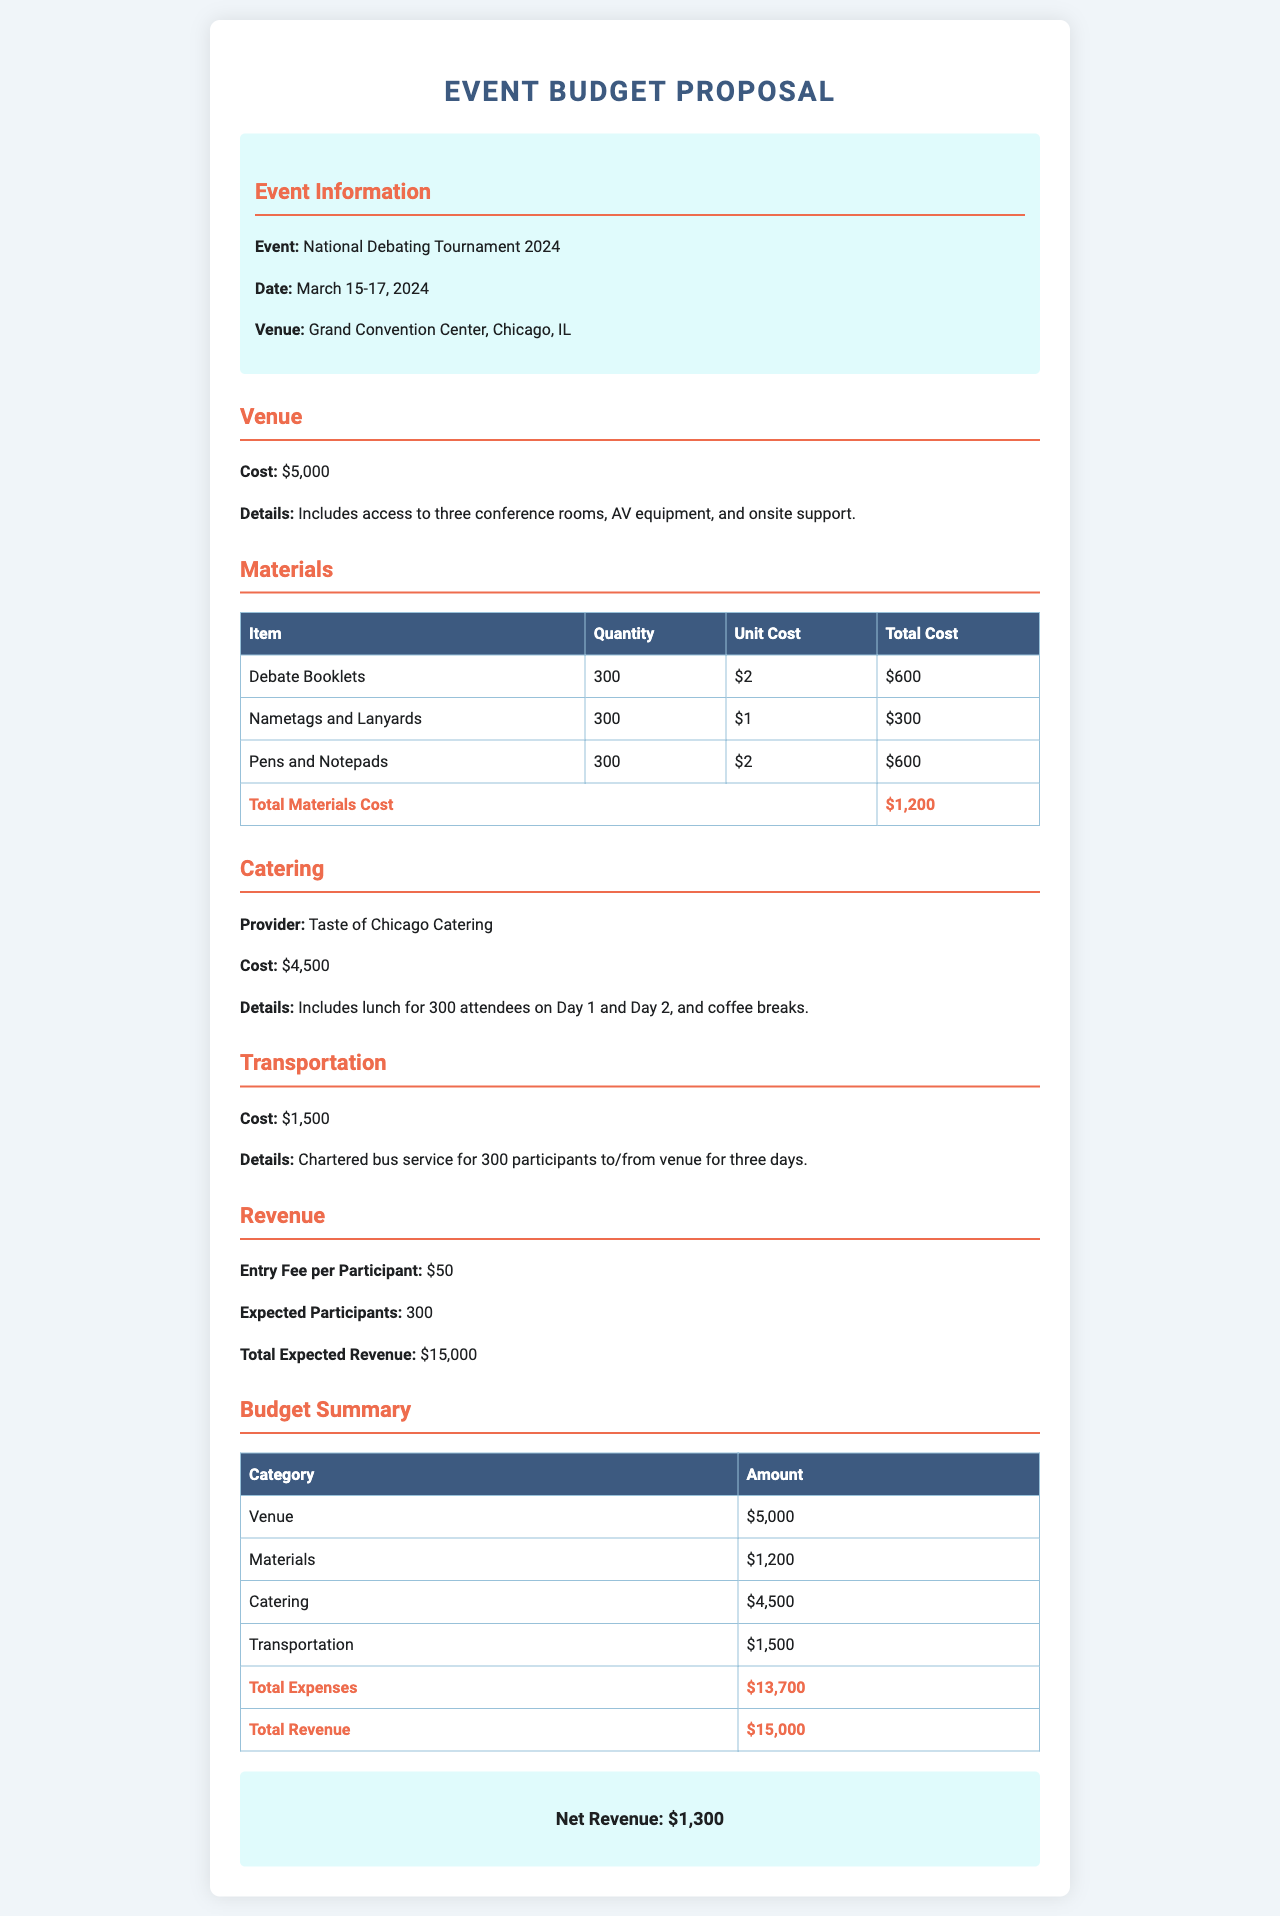What is the event date? The event date is specified in the document as March 15-17, 2024.
Answer: March 15-17, 2024 What is the total cost for the venue? The document lists the cost for the venue as $5,000.
Answer: $5,000 How many debate booklets are being printed? There are 300 debate booklets mentioned in the materials section of the document.
Answer: 300 What is the total expected revenue? The total expected revenue is calculated based on the entry fee and the expected number of participants, which is $15,000.
Answer: $15,000 What is the transportation cost? The cost for transportation is stated in the document as $1,500.
Answer: $1,500 How many participants are expected in the tournament? The expected number of participants mentioned in the document is 300.
Answer: 300 What is the net revenue? The net revenue is the difference between total revenue and total expenses, specified as $1,300 in the document.
Answer: $1,300 What catering provider is chosen for the event? The catering provider listed is "Taste of Chicago Catering."
Answer: Taste of Chicago Catering What is the total materials cost? The total materials cost is described in the document as $1,200.
Answer: $1,200 